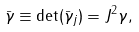<formula> <loc_0><loc_0><loc_500><loc_500>\bar { \gamma } \equiv \det ( \bar { \gamma } _ { j } ) = J ^ { 2 } \gamma ,</formula> 